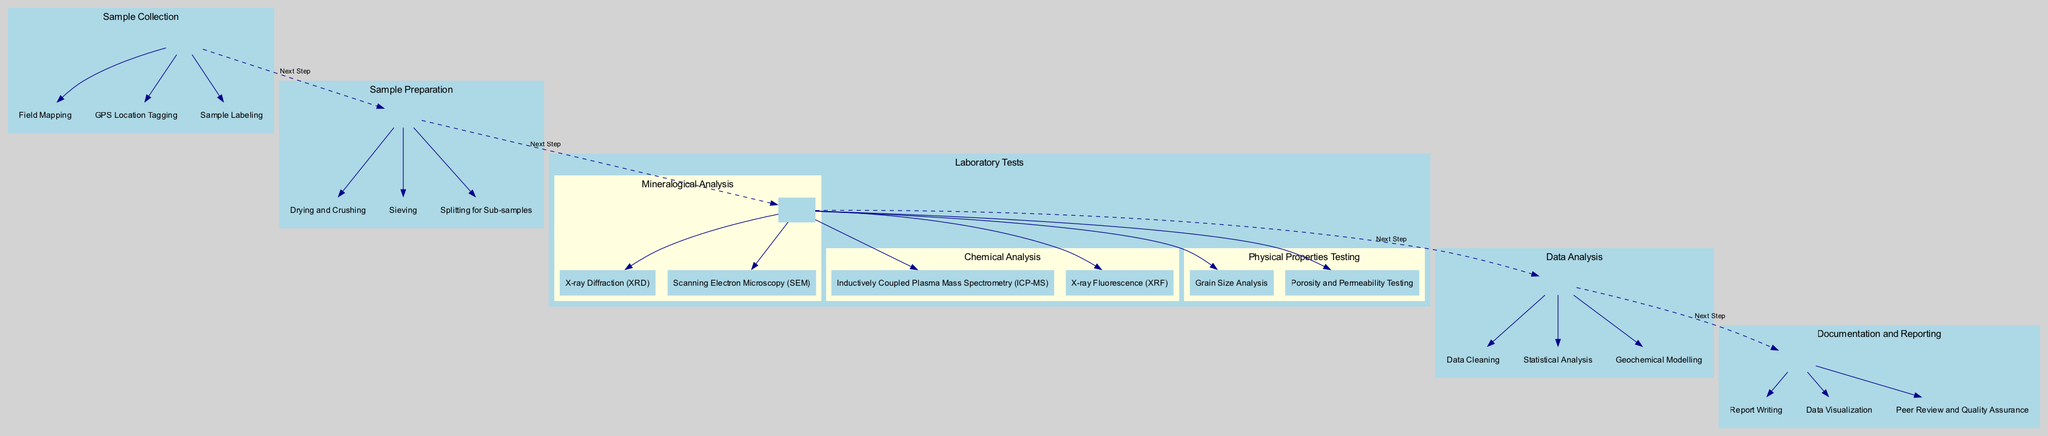What is the first step in the workflow? The first step is "Sample Collection" as indicated at the top of the diagram, showing that it is the starting point of the entire workflow process.
Answer: Sample Collection How many main steps are there in the workflow? By counting the distinct main steps displayed in the diagram, there are five main steps listed sequentially from Sample Collection to Documentation and Reporting.
Answer: Five What are the activities included in Sample Preparation? The activities are specifically listed under Sample Preparation in the diagram: "Drying and Crushing," "Sieving," and "Splitting for Sub-samples."
Answer: Drying and Crushing, Sieving, Splitting for Sub-samples Which laboratory test involves Scanning Electron Microscopy? The laboratory test that involves Scanning Electron Microscopy is "Mineralogical Analysis," as indicated in the Laboratory Tests section of the diagram.
Answer: Mineralogical Analysis What is the last stage mentioned in the workflow? The last stage is "Documentation and Reporting," showcasing that this step concludes the entire sample analysis workflow before dissemination of results.
Answer: Documentation and Reporting How many activities are listed under Chemical Analysis? In the "Laboratory Tests" section, under "Chemical Analysis," there are two activities mentioned: "Inductively Coupled Plasma Mass Spectrometry" and "X-ray Fluorescence."
Answer: Two Which step comes before Data Analysis? The step that comes before "Data Analysis" is "Laboratory Tests," as indicated by the dashed edge connecting these two steps in the diagram.
Answer: Laboratory Tests What is the main purpose of the Documentation and Reporting stage? The main purpose is to compile results into comprehensive reports for scientific publication or stakeholder reference, as described under this stage in the diagram.
Answer: Compile results into reports 